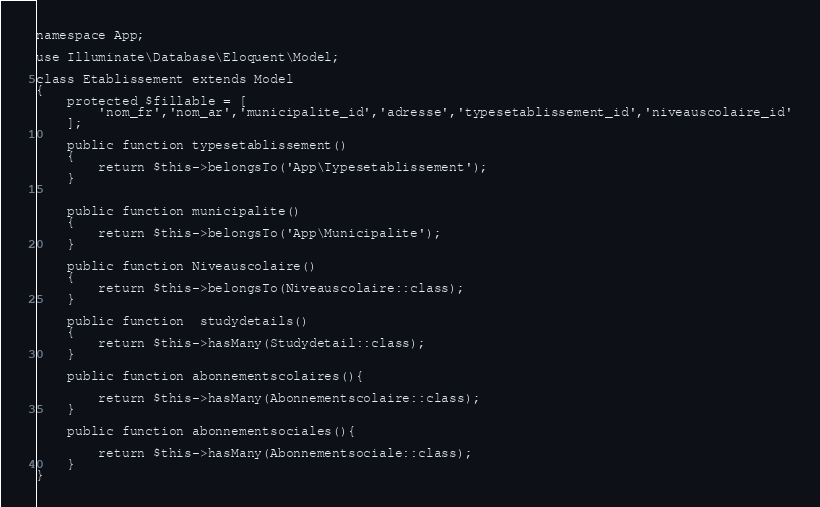Convert code to text. <code><loc_0><loc_0><loc_500><loc_500><_PHP_>
namespace App;

use Illuminate\Database\Eloquent\Model;

class Etablissement extends Model
{
    protected $fillable = [
        'nom_fr','nom_ar','municipalite_id','adresse','typesetablissement_id','niveauscolaire_id'
    ];

    public function typesetablissement()
    {
        return $this->belongsTo('App\Typesetablissement');
    }


    public function municipalite()
    {
        return $this->belongsTo('App\Municipalite');
    }

    public function Niveauscolaire()
    {
        return $this->belongsTo(Niveauscolaire::class);
    }

    public function  studydetails()
    {
        return $this->hasMany(Studydetail::class);
    }

    public function abonnementscolaires(){

        return $this->hasMany(Abonnementscolaire::class);
    }

    public function abonnementsociales(){

        return $this->hasMany(Abonnementsociale::class);
    }
}
</code> 